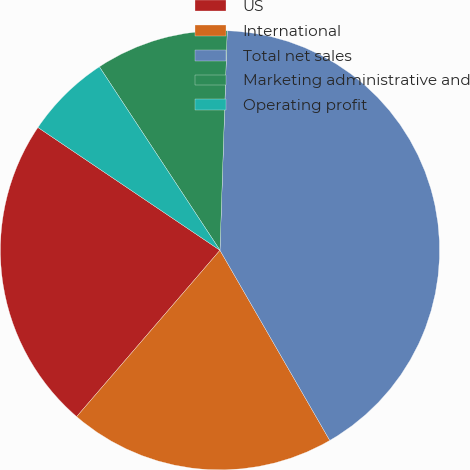<chart> <loc_0><loc_0><loc_500><loc_500><pie_chart><fcel>US<fcel>International<fcel>Total net sales<fcel>Marketing administrative and<fcel>Operating profit<nl><fcel>23.13%<fcel>19.65%<fcel>41.14%<fcel>9.78%<fcel>6.3%<nl></chart> 